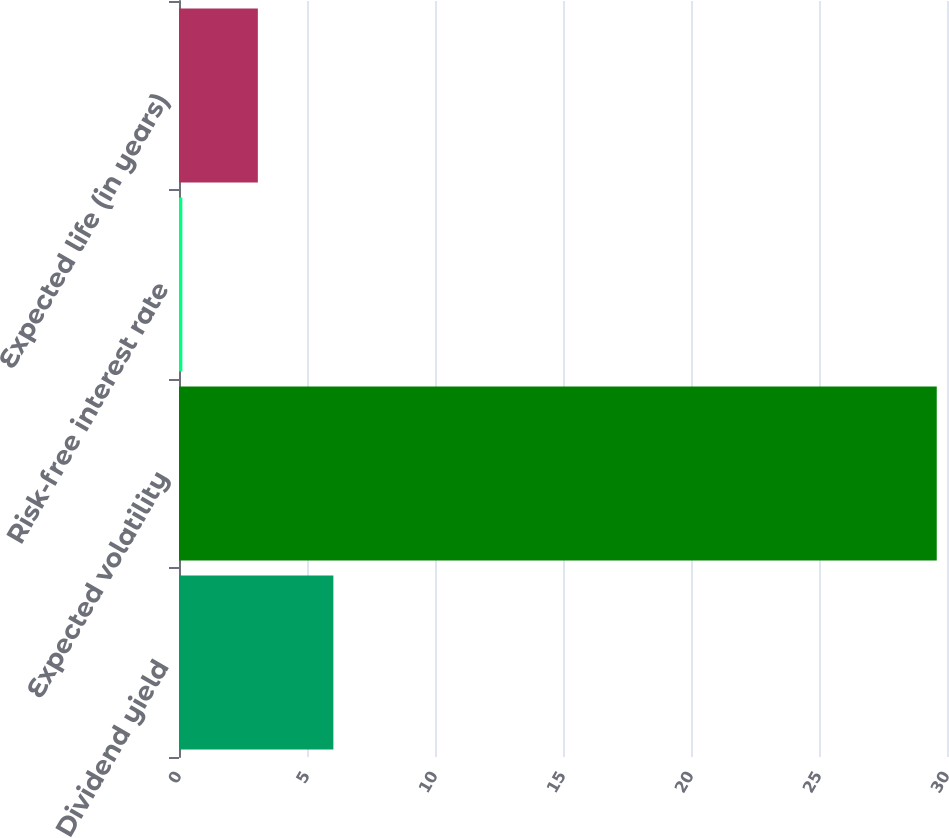<chart> <loc_0><loc_0><loc_500><loc_500><bar_chart><fcel>Dividend yield<fcel>Expected volatility<fcel>Risk-free interest rate<fcel>Expected life (in years)<nl><fcel>6.03<fcel>29.6<fcel>0.13<fcel>3.08<nl></chart> 